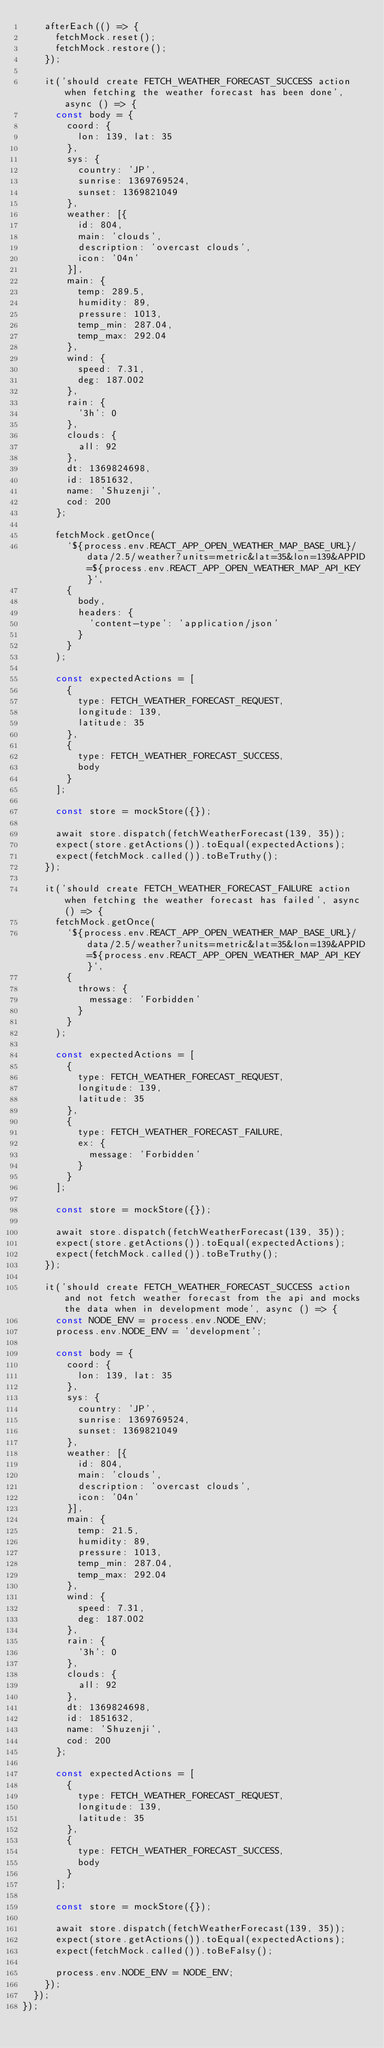Convert code to text. <code><loc_0><loc_0><loc_500><loc_500><_JavaScript_>    afterEach(() => {
      fetchMock.reset();
      fetchMock.restore();
    });

    it('should create FETCH_WEATHER_FORECAST_SUCCESS action when fetching the weather forecast has been done', async () => {
      const body = {
        coord: {
          lon: 139, lat: 35
        },
        sys: {
          country: 'JP',
          sunrise: 1369769524,
          sunset: 1369821049
        },
        weather: [{
          id: 804,
          main: 'clouds',
          description: 'overcast clouds',
          icon: '04n'
        }],
        main: {
          temp: 289.5,
          humidity: 89,
          pressure: 1013,
          temp_min: 287.04,
          temp_max: 292.04
        },
        wind: {
          speed: 7.31,
          deg: 187.002
        },
        rain: {
          '3h': 0
        },
        clouds: {
          all: 92
        },
        dt: 1369824698,
        id: 1851632,
        name: 'Shuzenji',
        cod: 200
      };

      fetchMock.getOnce(
        `${process.env.REACT_APP_OPEN_WEATHER_MAP_BASE_URL}/data/2.5/weather?units=metric&lat=35&lon=139&APPID=${process.env.REACT_APP_OPEN_WEATHER_MAP_API_KEY}`,
        {
          body,
          headers: {
            'content-type': 'application/json'
          }
        }
      );

      const expectedActions = [
        {
          type: FETCH_WEATHER_FORECAST_REQUEST,
          longitude: 139,
          latitude: 35
        },
        {
          type: FETCH_WEATHER_FORECAST_SUCCESS,
          body
        }
      ];

      const store = mockStore({});

      await store.dispatch(fetchWeatherForecast(139, 35));
      expect(store.getActions()).toEqual(expectedActions);
      expect(fetchMock.called()).toBeTruthy();
    });

    it('should create FETCH_WEATHER_FORECAST_FAILURE action when fetching the weather forecast has failed', async () => {
      fetchMock.getOnce(
        `${process.env.REACT_APP_OPEN_WEATHER_MAP_BASE_URL}/data/2.5/weather?units=metric&lat=35&lon=139&APPID=${process.env.REACT_APP_OPEN_WEATHER_MAP_API_KEY}`,
        {
          throws: {
            message: 'Forbidden'
          }
        }
      );

      const expectedActions = [
        {
          type: FETCH_WEATHER_FORECAST_REQUEST,
          longitude: 139,
          latitude: 35
        },
        {
          type: FETCH_WEATHER_FORECAST_FAILURE,
          ex: {
            message: 'Forbidden'
          }
        }
      ];

      const store = mockStore({});

      await store.dispatch(fetchWeatherForecast(139, 35));
      expect(store.getActions()).toEqual(expectedActions);
      expect(fetchMock.called()).toBeTruthy();
    });

    it('should create FETCH_WEATHER_FORECAST_SUCCESS action and not fetch weather forecast from the api and mocks the data when in development mode', async () => {
      const NODE_ENV = process.env.NODE_ENV;
      process.env.NODE_ENV = 'development';

      const body = {
        coord: {
          lon: 139, lat: 35
        },
        sys: {
          country: 'JP',
          sunrise: 1369769524,
          sunset: 1369821049
        },
        weather: [{
          id: 804,
          main: 'clouds',
          description: 'overcast clouds',
          icon: '04n'
        }],
        main: {
          temp: 21.5,
          humidity: 89,
          pressure: 1013,
          temp_min: 287.04,
          temp_max: 292.04
        },
        wind: {
          speed: 7.31,
          deg: 187.002
        },
        rain: {
          '3h': 0
        },
        clouds: {
          all: 92
        },
        dt: 1369824698,
        id: 1851632,
        name: 'Shuzenji',
        cod: 200
      };

      const expectedActions = [
        {
          type: FETCH_WEATHER_FORECAST_REQUEST,
          longitude: 139,
          latitude: 35
        },
        {
          type: FETCH_WEATHER_FORECAST_SUCCESS,
          body
        }
      ];

      const store = mockStore({});

      await store.dispatch(fetchWeatherForecast(139, 35));
      expect(store.getActions()).toEqual(expectedActions);
      expect(fetchMock.called()).toBeFalsy();

      process.env.NODE_ENV = NODE_ENV;
    });
  });
});
</code> 